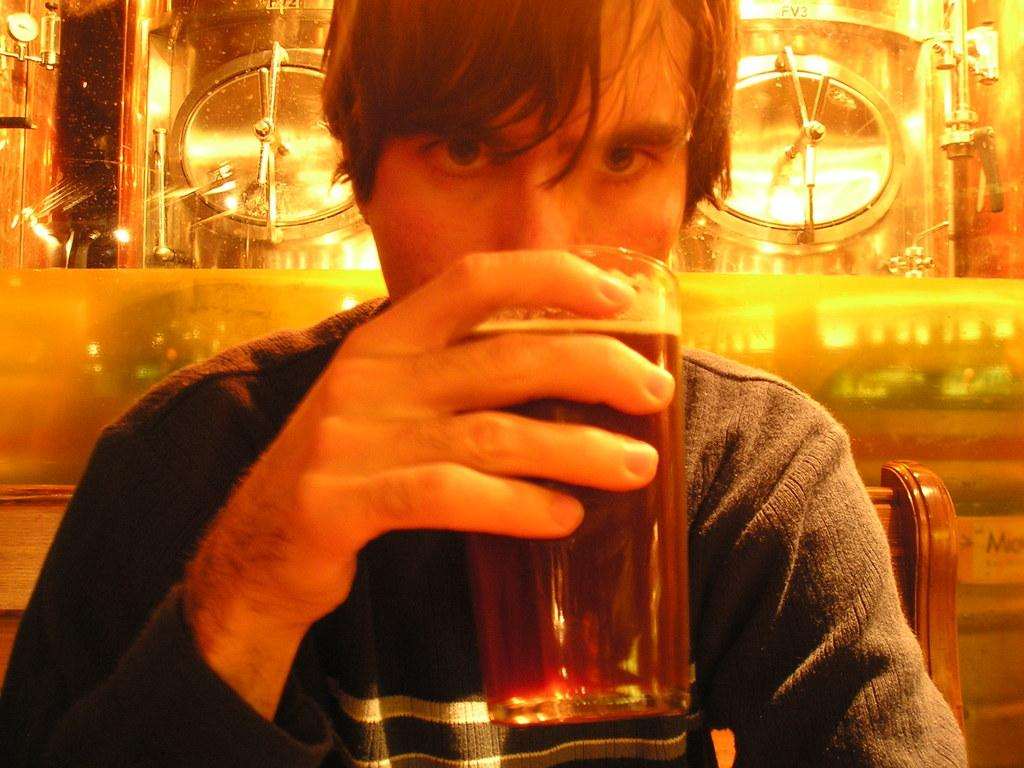What is the man in the image doing? The man is sitting on a chair in the image. What is the man holding in the image? The man is drinking wine. What can be seen in the background of the image? There is a glass wardrobe in the background of the image. What type of dish is present in the image? There is a round golden dish in the image. What type of grass is growing in the image? There is no grass present in the image. What type of plantation can be seen in the background of the image? There is no plantation present in the image; it features a glass wardrobe in the background. 